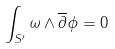Convert formula to latex. <formula><loc_0><loc_0><loc_500><loc_500>\int _ { S ^ { \prime } } \omega \wedge \overline { \partial } \phi = 0</formula> 